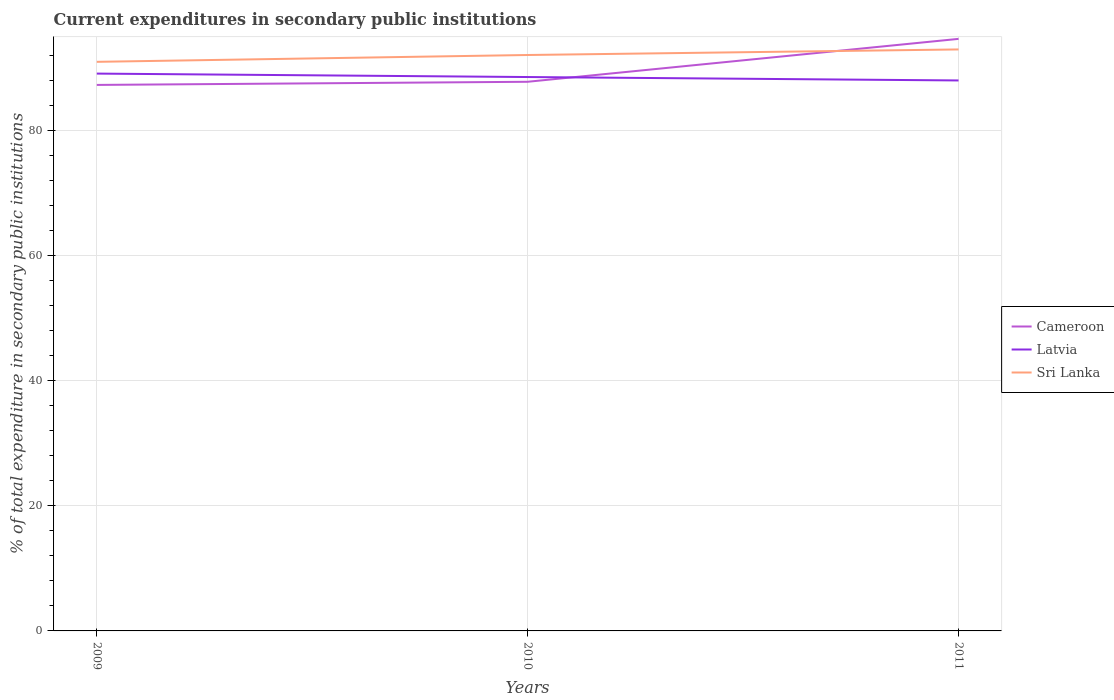Does the line corresponding to Latvia intersect with the line corresponding to Cameroon?
Your answer should be very brief. Yes. Is the number of lines equal to the number of legend labels?
Provide a succinct answer. Yes. Across all years, what is the maximum current expenditures in secondary public institutions in Latvia?
Your response must be concise. 88.02. In which year was the current expenditures in secondary public institutions in Cameroon maximum?
Provide a short and direct response. 2009. What is the total current expenditures in secondary public institutions in Sri Lanka in the graph?
Offer a very short reply. -1.09. What is the difference between the highest and the second highest current expenditures in secondary public institutions in Sri Lanka?
Provide a succinct answer. 1.98. What is the difference between the highest and the lowest current expenditures in secondary public institutions in Sri Lanka?
Provide a short and direct response. 2. Is the current expenditures in secondary public institutions in Sri Lanka strictly greater than the current expenditures in secondary public institutions in Latvia over the years?
Ensure brevity in your answer.  No. How many lines are there?
Offer a very short reply. 3. How many years are there in the graph?
Provide a short and direct response. 3. Are the values on the major ticks of Y-axis written in scientific E-notation?
Provide a succinct answer. No. Does the graph contain any zero values?
Give a very brief answer. No. Does the graph contain grids?
Provide a short and direct response. Yes. Where does the legend appear in the graph?
Offer a terse response. Center right. How many legend labels are there?
Keep it short and to the point. 3. How are the legend labels stacked?
Your response must be concise. Vertical. What is the title of the graph?
Your answer should be compact. Current expenditures in secondary public institutions. Does "Moldova" appear as one of the legend labels in the graph?
Provide a short and direct response. No. What is the label or title of the Y-axis?
Your answer should be very brief. % of total expenditure in secondary public institutions. What is the % of total expenditure in secondary public institutions in Cameroon in 2009?
Your response must be concise. 87.31. What is the % of total expenditure in secondary public institutions of Latvia in 2009?
Your answer should be very brief. 89.12. What is the % of total expenditure in secondary public institutions in Sri Lanka in 2009?
Make the answer very short. 91. What is the % of total expenditure in secondary public institutions of Cameroon in 2010?
Provide a succinct answer. 87.81. What is the % of total expenditure in secondary public institutions in Latvia in 2010?
Give a very brief answer. 88.57. What is the % of total expenditure in secondary public institutions in Sri Lanka in 2010?
Offer a terse response. 92.09. What is the % of total expenditure in secondary public institutions in Cameroon in 2011?
Your answer should be compact. 94.67. What is the % of total expenditure in secondary public institutions in Latvia in 2011?
Make the answer very short. 88.02. What is the % of total expenditure in secondary public institutions in Sri Lanka in 2011?
Provide a short and direct response. 92.98. Across all years, what is the maximum % of total expenditure in secondary public institutions of Cameroon?
Ensure brevity in your answer.  94.67. Across all years, what is the maximum % of total expenditure in secondary public institutions of Latvia?
Your response must be concise. 89.12. Across all years, what is the maximum % of total expenditure in secondary public institutions of Sri Lanka?
Your answer should be compact. 92.98. Across all years, what is the minimum % of total expenditure in secondary public institutions in Cameroon?
Offer a terse response. 87.31. Across all years, what is the minimum % of total expenditure in secondary public institutions in Latvia?
Provide a succinct answer. 88.02. Across all years, what is the minimum % of total expenditure in secondary public institutions in Sri Lanka?
Make the answer very short. 91. What is the total % of total expenditure in secondary public institutions in Cameroon in the graph?
Your answer should be very brief. 269.79. What is the total % of total expenditure in secondary public institutions in Latvia in the graph?
Provide a short and direct response. 265.71. What is the total % of total expenditure in secondary public institutions in Sri Lanka in the graph?
Keep it short and to the point. 276.08. What is the difference between the % of total expenditure in secondary public institutions of Cameroon in 2009 and that in 2010?
Make the answer very short. -0.5. What is the difference between the % of total expenditure in secondary public institutions in Latvia in 2009 and that in 2010?
Provide a succinct answer. 0.55. What is the difference between the % of total expenditure in secondary public institutions of Sri Lanka in 2009 and that in 2010?
Your answer should be compact. -1.09. What is the difference between the % of total expenditure in secondary public institutions of Cameroon in 2009 and that in 2011?
Your response must be concise. -7.36. What is the difference between the % of total expenditure in secondary public institutions in Latvia in 2009 and that in 2011?
Your answer should be compact. 1.1. What is the difference between the % of total expenditure in secondary public institutions in Sri Lanka in 2009 and that in 2011?
Your response must be concise. -1.98. What is the difference between the % of total expenditure in secondary public institutions of Cameroon in 2010 and that in 2011?
Offer a terse response. -6.86. What is the difference between the % of total expenditure in secondary public institutions in Latvia in 2010 and that in 2011?
Keep it short and to the point. 0.55. What is the difference between the % of total expenditure in secondary public institutions of Sri Lanka in 2010 and that in 2011?
Ensure brevity in your answer.  -0.89. What is the difference between the % of total expenditure in secondary public institutions of Cameroon in 2009 and the % of total expenditure in secondary public institutions of Latvia in 2010?
Your answer should be compact. -1.26. What is the difference between the % of total expenditure in secondary public institutions in Cameroon in 2009 and the % of total expenditure in secondary public institutions in Sri Lanka in 2010?
Keep it short and to the point. -4.79. What is the difference between the % of total expenditure in secondary public institutions of Latvia in 2009 and the % of total expenditure in secondary public institutions of Sri Lanka in 2010?
Make the answer very short. -2.97. What is the difference between the % of total expenditure in secondary public institutions in Cameroon in 2009 and the % of total expenditure in secondary public institutions in Latvia in 2011?
Provide a short and direct response. -0.71. What is the difference between the % of total expenditure in secondary public institutions in Cameroon in 2009 and the % of total expenditure in secondary public institutions in Sri Lanka in 2011?
Your answer should be very brief. -5.67. What is the difference between the % of total expenditure in secondary public institutions of Latvia in 2009 and the % of total expenditure in secondary public institutions of Sri Lanka in 2011?
Ensure brevity in your answer.  -3.86. What is the difference between the % of total expenditure in secondary public institutions in Cameroon in 2010 and the % of total expenditure in secondary public institutions in Latvia in 2011?
Keep it short and to the point. -0.21. What is the difference between the % of total expenditure in secondary public institutions of Cameroon in 2010 and the % of total expenditure in secondary public institutions of Sri Lanka in 2011?
Give a very brief answer. -5.17. What is the difference between the % of total expenditure in secondary public institutions of Latvia in 2010 and the % of total expenditure in secondary public institutions of Sri Lanka in 2011?
Provide a short and direct response. -4.41. What is the average % of total expenditure in secondary public institutions in Cameroon per year?
Your answer should be compact. 89.93. What is the average % of total expenditure in secondary public institutions in Latvia per year?
Offer a terse response. 88.57. What is the average % of total expenditure in secondary public institutions of Sri Lanka per year?
Provide a short and direct response. 92.03. In the year 2009, what is the difference between the % of total expenditure in secondary public institutions of Cameroon and % of total expenditure in secondary public institutions of Latvia?
Give a very brief answer. -1.81. In the year 2009, what is the difference between the % of total expenditure in secondary public institutions in Cameroon and % of total expenditure in secondary public institutions in Sri Lanka?
Provide a succinct answer. -3.69. In the year 2009, what is the difference between the % of total expenditure in secondary public institutions of Latvia and % of total expenditure in secondary public institutions of Sri Lanka?
Offer a very short reply. -1.88. In the year 2010, what is the difference between the % of total expenditure in secondary public institutions in Cameroon and % of total expenditure in secondary public institutions in Latvia?
Your answer should be compact. -0.76. In the year 2010, what is the difference between the % of total expenditure in secondary public institutions in Cameroon and % of total expenditure in secondary public institutions in Sri Lanka?
Ensure brevity in your answer.  -4.28. In the year 2010, what is the difference between the % of total expenditure in secondary public institutions in Latvia and % of total expenditure in secondary public institutions in Sri Lanka?
Your answer should be compact. -3.52. In the year 2011, what is the difference between the % of total expenditure in secondary public institutions in Cameroon and % of total expenditure in secondary public institutions in Latvia?
Provide a succinct answer. 6.65. In the year 2011, what is the difference between the % of total expenditure in secondary public institutions in Cameroon and % of total expenditure in secondary public institutions in Sri Lanka?
Keep it short and to the point. 1.69. In the year 2011, what is the difference between the % of total expenditure in secondary public institutions of Latvia and % of total expenditure in secondary public institutions of Sri Lanka?
Provide a succinct answer. -4.96. What is the ratio of the % of total expenditure in secondary public institutions in Cameroon in 2009 to that in 2010?
Your answer should be compact. 0.99. What is the ratio of the % of total expenditure in secondary public institutions in Latvia in 2009 to that in 2010?
Provide a succinct answer. 1.01. What is the ratio of the % of total expenditure in secondary public institutions in Sri Lanka in 2009 to that in 2010?
Make the answer very short. 0.99. What is the ratio of the % of total expenditure in secondary public institutions in Cameroon in 2009 to that in 2011?
Provide a succinct answer. 0.92. What is the ratio of the % of total expenditure in secondary public institutions in Latvia in 2009 to that in 2011?
Ensure brevity in your answer.  1.01. What is the ratio of the % of total expenditure in secondary public institutions of Sri Lanka in 2009 to that in 2011?
Make the answer very short. 0.98. What is the ratio of the % of total expenditure in secondary public institutions of Cameroon in 2010 to that in 2011?
Offer a terse response. 0.93. What is the difference between the highest and the second highest % of total expenditure in secondary public institutions in Cameroon?
Offer a very short reply. 6.86. What is the difference between the highest and the second highest % of total expenditure in secondary public institutions of Latvia?
Your answer should be compact. 0.55. What is the difference between the highest and the second highest % of total expenditure in secondary public institutions in Sri Lanka?
Your answer should be compact. 0.89. What is the difference between the highest and the lowest % of total expenditure in secondary public institutions in Cameroon?
Offer a very short reply. 7.36. What is the difference between the highest and the lowest % of total expenditure in secondary public institutions of Latvia?
Your answer should be very brief. 1.1. What is the difference between the highest and the lowest % of total expenditure in secondary public institutions of Sri Lanka?
Provide a succinct answer. 1.98. 